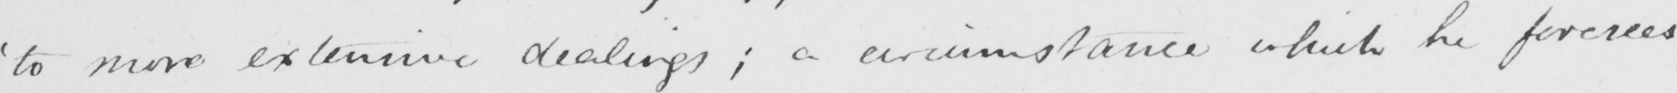Can you tell me what this handwritten text says? ' to more extensive dealings ; a circumstance which he foresees 